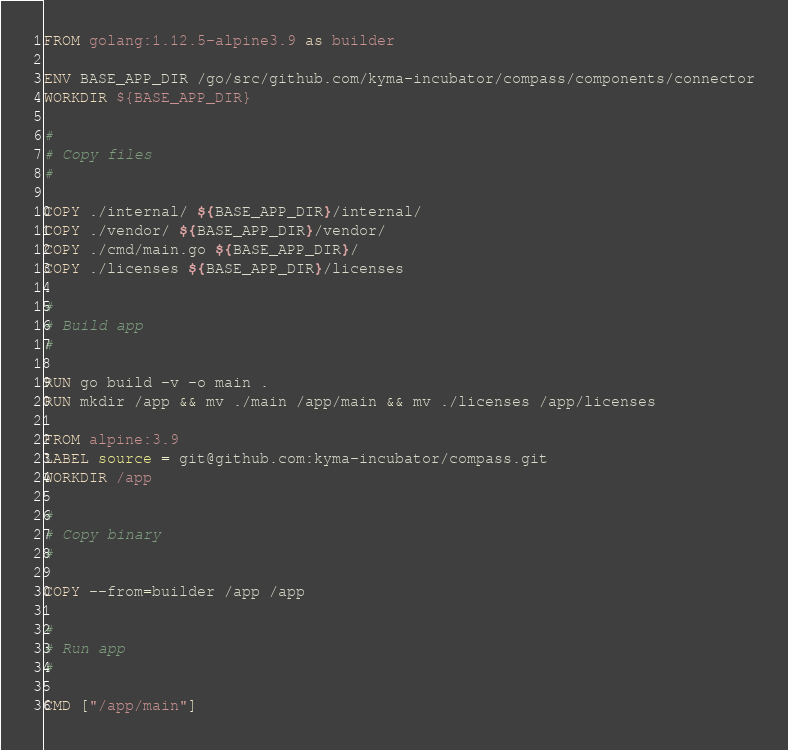Convert code to text. <code><loc_0><loc_0><loc_500><loc_500><_Dockerfile_>FROM golang:1.12.5-alpine3.9 as builder

ENV BASE_APP_DIR /go/src/github.com/kyma-incubator/compass/components/connector
WORKDIR ${BASE_APP_DIR}

#
# Copy files
#

COPY ./internal/ ${BASE_APP_DIR}/internal/
COPY ./vendor/ ${BASE_APP_DIR}/vendor/
COPY ./cmd/main.go ${BASE_APP_DIR}/
COPY ./licenses ${BASE_APP_DIR}/licenses

#
# Build app
#

RUN go build -v -o main .
RUN mkdir /app && mv ./main /app/main && mv ./licenses /app/licenses

FROM alpine:3.9
LABEL source = git@github.com:kyma-incubator/compass.git
WORKDIR /app

#
# Copy binary
#

COPY --from=builder /app /app

#
# Run app
#

CMD ["/app/main"]
</code> 